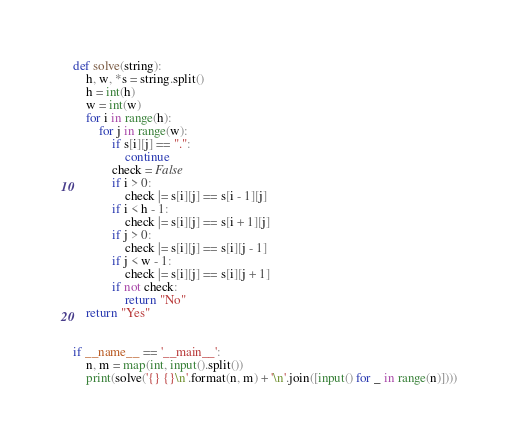Convert code to text. <code><loc_0><loc_0><loc_500><loc_500><_Python_>def solve(string):
    h, w, *s = string.split()
    h = int(h)
    w = int(w)
    for i in range(h):
        for j in range(w):
            if s[i][j] == ".":
                continue
            check = False
            if i > 0:
                check |= s[i][j] == s[i - 1][j]
            if i < h - 1:
                check |= s[i][j] == s[i + 1][j]
            if j > 0:
                check |= s[i][j] == s[i][j - 1]
            if j < w - 1:
                check |= s[i][j] == s[i][j + 1]
            if not check:
                return "No"
    return "Yes"


if __name__ == '__main__':
    n, m = map(int, input().split())
    print(solve('{} {}\n'.format(n, m) + '\n'.join([input() for _ in range(n)])))
</code> 